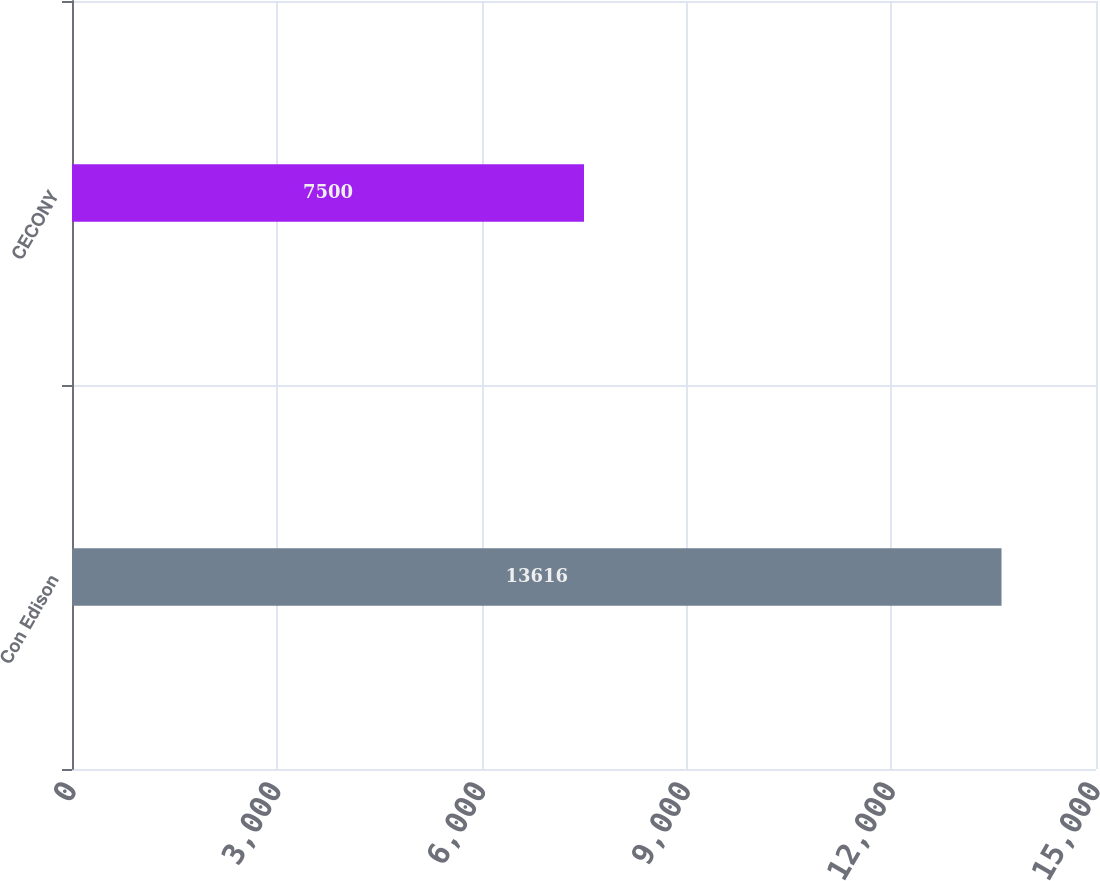Convert chart to OTSL. <chart><loc_0><loc_0><loc_500><loc_500><bar_chart><fcel>Con Edison<fcel>CECONY<nl><fcel>13616<fcel>7500<nl></chart> 